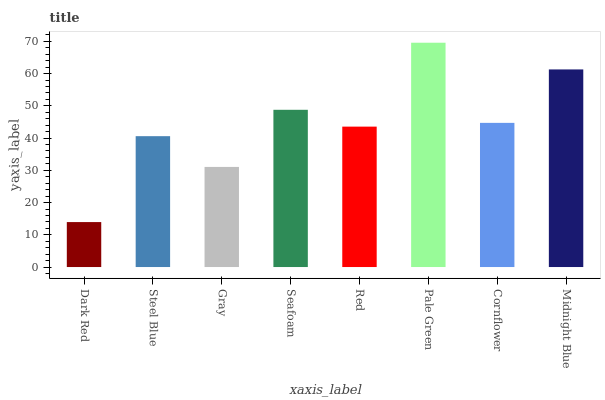Is Dark Red the minimum?
Answer yes or no. Yes. Is Pale Green the maximum?
Answer yes or no. Yes. Is Steel Blue the minimum?
Answer yes or no. No. Is Steel Blue the maximum?
Answer yes or no. No. Is Steel Blue greater than Dark Red?
Answer yes or no. Yes. Is Dark Red less than Steel Blue?
Answer yes or no. Yes. Is Dark Red greater than Steel Blue?
Answer yes or no. No. Is Steel Blue less than Dark Red?
Answer yes or no. No. Is Cornflower the high median?
Answer yes or no. Yes. Is Red the low median?
Answer yes or no. Yes. Is Midnight Blue the high median?
Answer yes or no. No. Is Dark Red the low median?
Answer yes or no. No. 